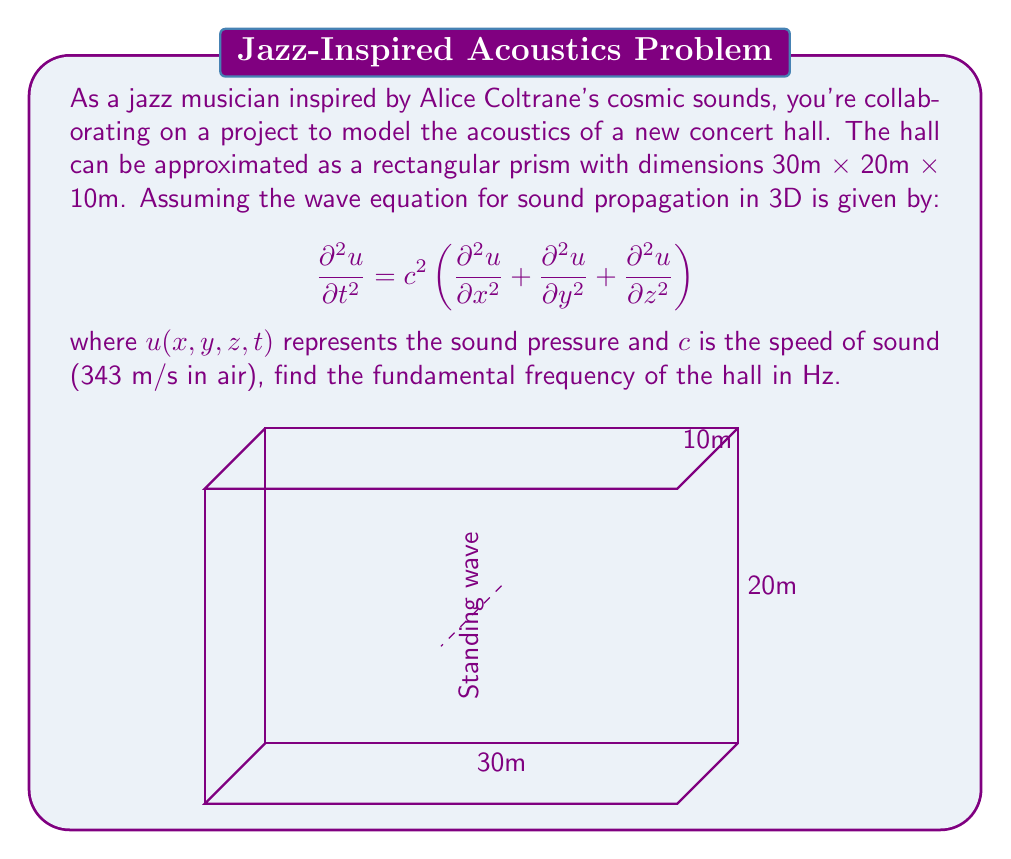Teach me how to tackle this problem. To solve this problem, we'll follow these steps:

1) The fundamental frequency corresponds to the lowest-energy standing wave in the hall. For a rectangular room, this occurs when half a wavelength fits in each dimension.

2) The wave equation solution for standing waves in a rectangular room has the form:

   $$u(x,y,z,t) = \sin(k_x x) \sin(k_y y) \sin(k_z z) \cos(\omega t)$$

   where $k_x$, $k_y$, and $k_z$ are wave numbers in each direction.

3) For the fundamental mode, we have:

   $$k_x = \frac{\pi}{L_x}, k_y = \frac{\pi}{L_y}, k_z = \frac{\pi}{L_z}$$

   where $L_x = 30$m, $L_y = 20$m, and $L_z = 10$m.

4) The wave numbers are related to the angular frequency $\omega$ by:

   $$\omega^2 = c^2(k_x^2 + k_y^2 + k_z^2)$$

5) Substituting the values:

   $$\omega^2 = c^2 \left[\left(\frac{\pi}{30}\right)^2 + \left(\frac{\pi}{20}\right)^2 + \left(\frac{\pi}{10}\right)^2\right]$$

6) The frequency $f$ is related to $\omega$ by $\omega = 2\pi f$. So:

   $$f = \frac{c}{2\pi}\sqrt{\left(\frac{\pi}{30}\right)^2 + \left(\frac{\pi}{20}\right)^2 + \left(\frac{\pi}{10}\right)^2}$$

7) Plugging in $c = 343$ m/s and calculating:

   $$f = \frac{343}{2\pi}\sqrt{\frac{\pi^2}{900} + \frac{\pi^2}{400} + \frac{\pi^2}{100}} \approx 17.15 \text{ Hz}$$
Answer: 17.15 Hz 